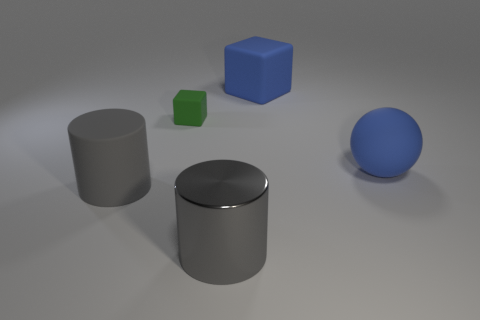Add 1 large blue objects. How many objects exist? 6 Subtract 1 cylinders. How many cylinders are left? 1 Subtract all blue balls. How many blue cubes are left? 1 Subtract all green cubes. Subtract all big matte objects. How many objects are left? 1 Add 1 small rubber blocks. How many small rubber blocks are left? 2 Add 5 small blue matte things. How many small blue matte things exist? 5 Subtract all blue blocks. How many blocks are left? 1 Subtract 0 red blocks. How many objects are left? 5 Subtract all blocks. How many objects are left? 3 Subtract all green cylinders. Subtract all brown blocks. How many cylinders are left? 2 